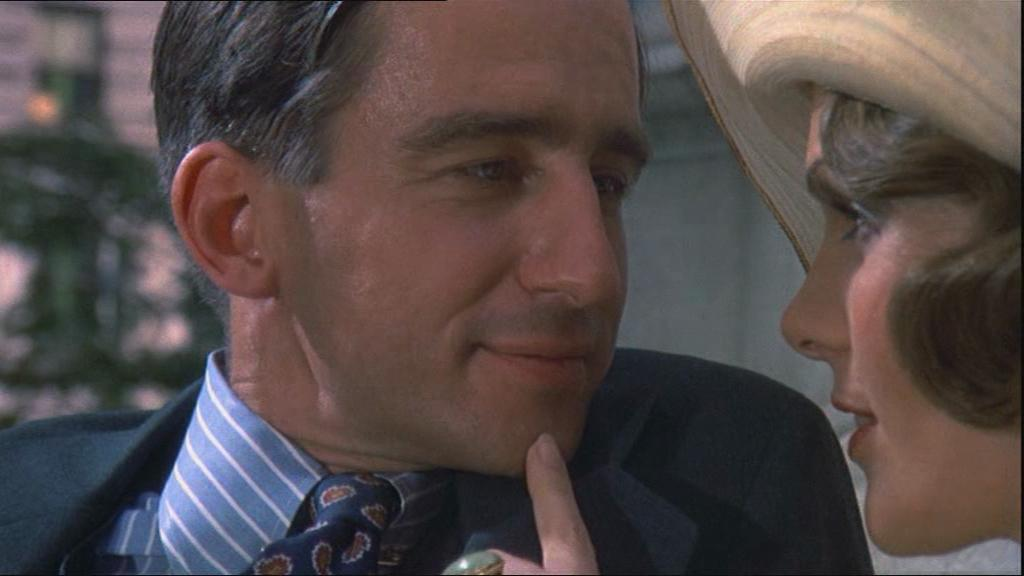How many people are in the image? There are two people in the foreground of the image. Can you describe the person on the right side of the image? The person on the right side of the image is wearing a cap. What can be observed about the background of the image? The background of the image is blurry. What school does the person's grandmother teach at in the image? There is no school or grandmother present in the image. 